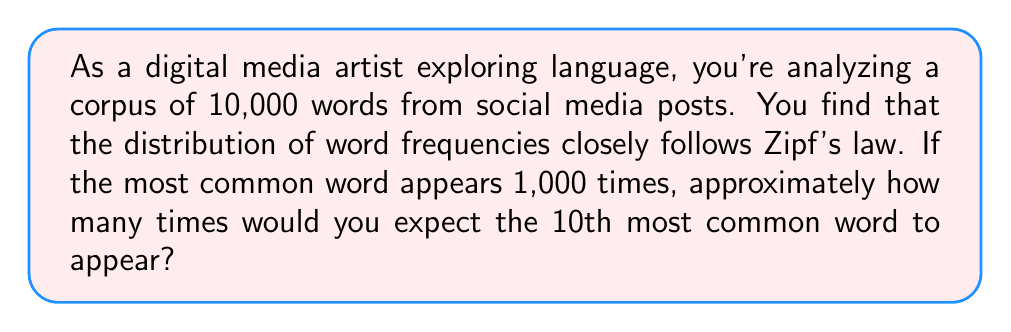Show me your answer to this math problem. To solve this problem, we need to understand and apply Zipf's law in the context of word frequencies. Let's break it down step-by-step:

1) Zipf's law states that the frequency of any word is inversely proportional to its rank in the frequency table. Mathematically, this can be expressed as:

   $$f(k) \propto \frac{1}{k^s}$$

   where $f(k)$ is the frequency of the word with rank $k$, and $s$ is a parameter close to 1 for human languages.

2) For simplicity, let's assume $s = 1$ (which is often a good approximation). Then we can write:

   $$f(k) = \frac{C}{k}$$

   where $C$ is a constant.

3) We're given that the most common word (rank 1) appears 1,000 times. So:

   $$f(1) = 1000 = \frac{C}{1}$$

   Therefore, $C = 1000$.

4) Now, we want to find $f(10)$, the frequency of the 10th most common word:

   $$f(10) = \frac{C}{10} = \frac{1000}{10} = 100$$

5) To verify this follows the distribution, we can check a few more points:
   - 2nd most common word: $f(2) = 1000/2 = 500$
   - 5th most common word: $f(5) = 1000/5 = 200$

This progression aligns with the expected distribution from Zipf's law.
Answer: According to Zipf's law, the 10th most common word would be expected to appear approximately 100 times in the corpus. 